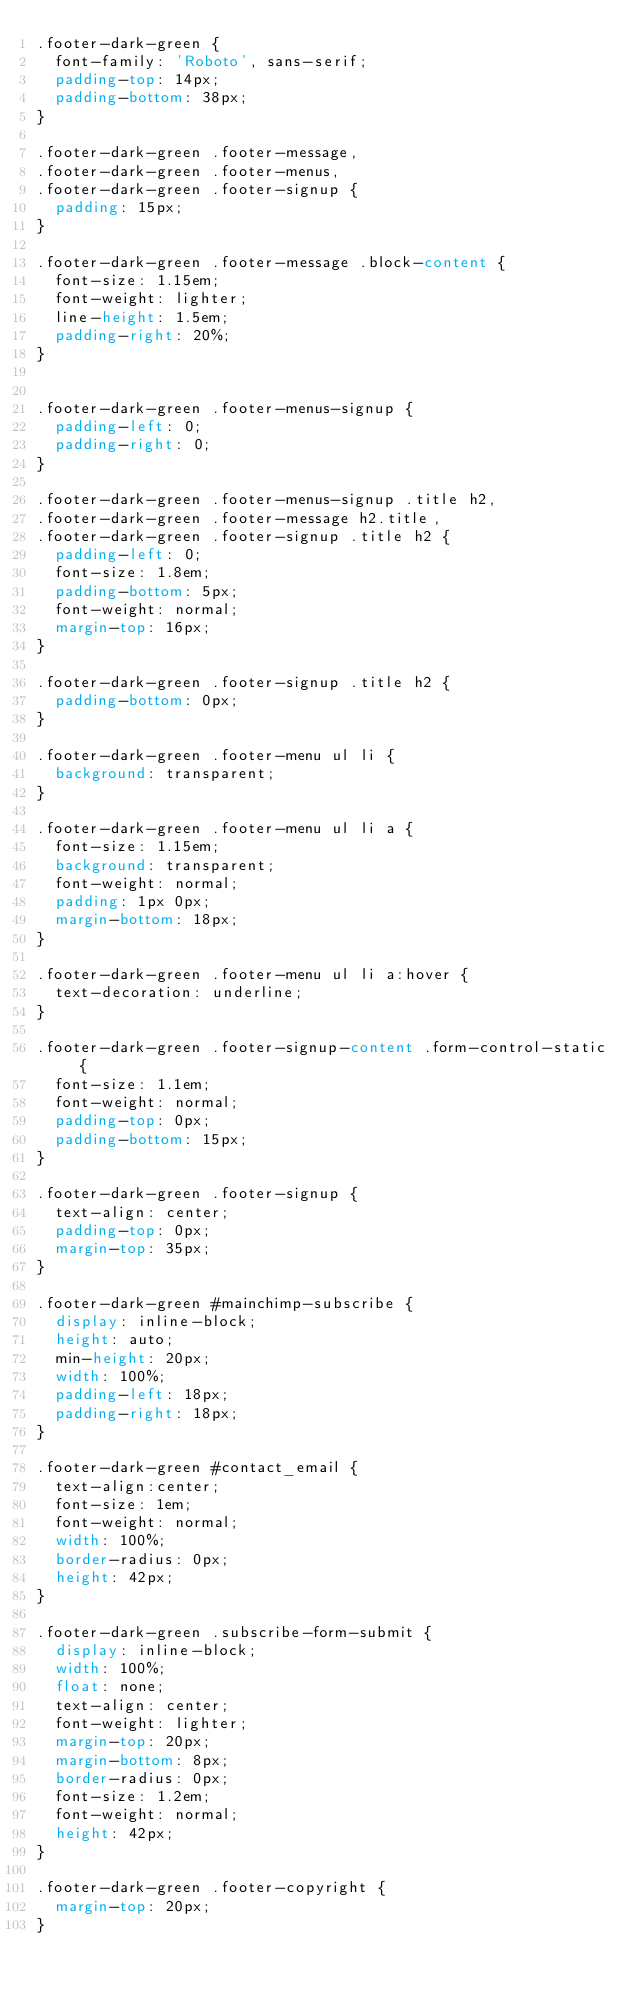<code> <loc_0><loc_0><loc_500><loc_500><_CSS_>.footer-dark-green {
  font-family: 'Roboto', sans-serif;
  padding-top: 14px;
  padding-bottom: 38px;
}

.footer-dark-green .footer-message,
.footer-dark-green .footer-menus,
.footer-dark-green .footer-signup {
  padding: 15px;
}
 
.footer-dark-green .footer-message .block-content {
  font-size: 1.15em;
  font-weight: lighter;
  line-height: 1.5em;
  padding-right: 20%;
}


.footer-dark-green .footer-menus-signup {
  padding-left: 0;
  padding-right: 0;
}  

.footer-dark-green .footer-menus-signup .title h2,
.footer-dark-green .footer-message h2.title,
.footer-dark-green .footer-signup .title h2 {
  padding-left: 0;
  font-size: 1.8em;
  padding-bottom: 5px;
  font-weight: normal;
  margin-top: 16px;
}

.footer-dark-green .footer-signup .title h2 {
  padding-bottom: 0px;  
}

.footer-dark-green .footer-menu ul li {
  background: transparent;
}

.footer-dark-green .footer-menu ul li a {
  font-size: 1.15em;
  background: transparent;
  font-weight: normal;
  padding: 1px 0px;
  margin-bottom: 18px;
}  
 
.footer-dark-green .footer-menu ul li a:hover {
  text-decoration: underline;
} 

.footer-dark-green .footer-signup-content .form-control-static {
  font-size: 1.1em;
  font-weight: normal;
  padding-top: 0px;
  padding-bottom: 15px;
}

.footer-dark-green .footer-signup {
  text-align: center;
  padding-top: 0px;
  margin-top: 35px;
}
  
.footer-dark-green #mainchimp-subscribe {
  display: inline-block;
  height: auto;
  min-height: 20px;
  width: 100%;
  padding-left: 18px;
  padding-right: 18px;
}
  
.footer-dark-green #contact_email {
  text-align:center;
  font-size: 1em;
  font-weight: normal;
  width: 100%;
  border-radius: 0px;
  height: 42px;
}
  
.footer-dark-green .subscribe-form-submit {
  display: inline-block;
  width: 100%;
  float: none;
  text-align: center;
  font-weight: lighter;
  margin-top: 20px;
  margin-bottom: 8px;
  border-radius: 0px;
  font-size: 1.2em;
  font-weight: normal;
  height: 42px;
}  

.footer-dark-green .footer-copyright {
  margin-top: 20px;
}</code> 